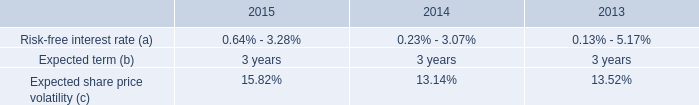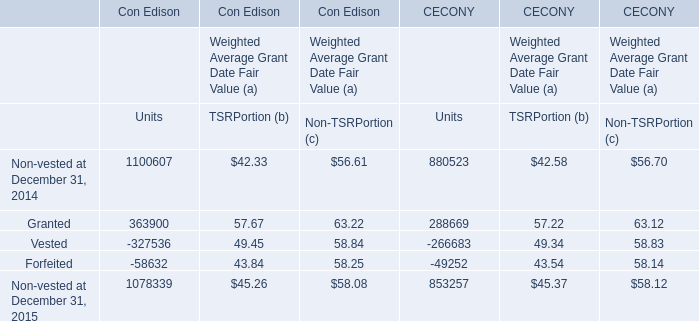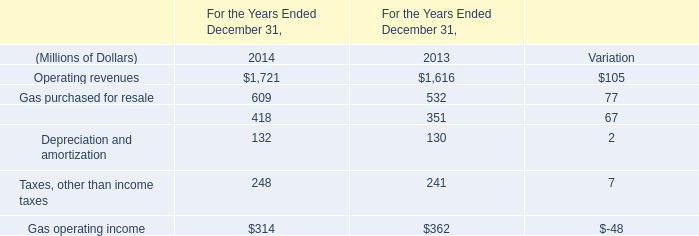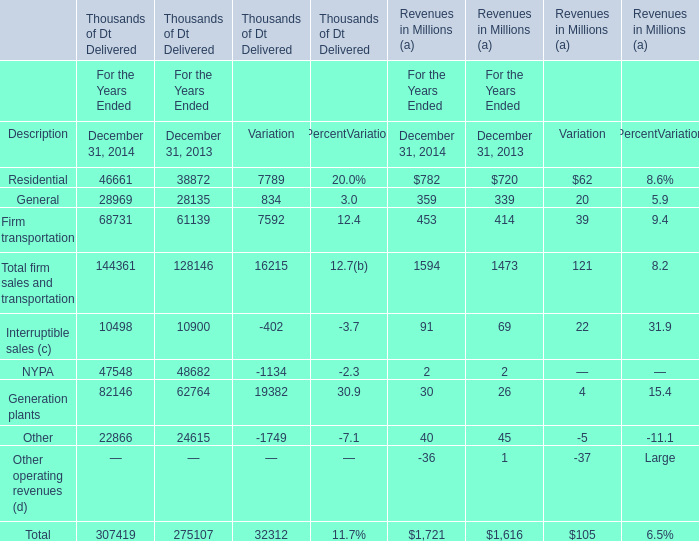Which year is General for Thousands of Dt Delivered greater than 28000 ? 
Answer: 2014. 